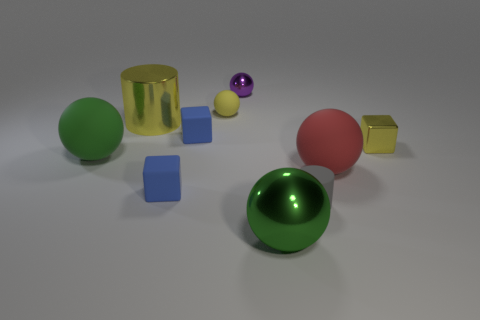Is the large green metallic thing the same shape as the big red object?
Make the answer very short. Yes. There is a yellow metal object on the right side of the metal object that is in front of the large red ball; what number of blue objects are behind it?
Make the answer very short. 1. What material is the object that is both behind the big red sphere and to the right of the gray object?
Ensure brevity in your answer.  Metal. There is a tiny object that is behind the red rubber object and on the right side of the small purple metallic thing; what is its color?
Your response must be concise. Yellow. Is there anything else that is the same color as the large shiny cylinder?
Keep it short and to the point. Yes. The big green object that is in front of the large rubber thing that is on the left side of the big green metal object on the left side of the small gray rubber object is what shape?
Give a very brief answer. Sphere. What is the color of the other metallic object that is the same shape as the green metal object?
Ensure brevity in your answer.  Purple. What is the color of the shiny cylinder to the left of the metallic ball in front of the gray rubber thing?
Give a very brief answer. Yellow. What is the size of the other metal thing that is the same shape as the purple metallic thing?
Offer a terse response. Large. How many big green objects are made of the same material as the tiny yellow ball?
Ensure brevity in your answer.  1. 